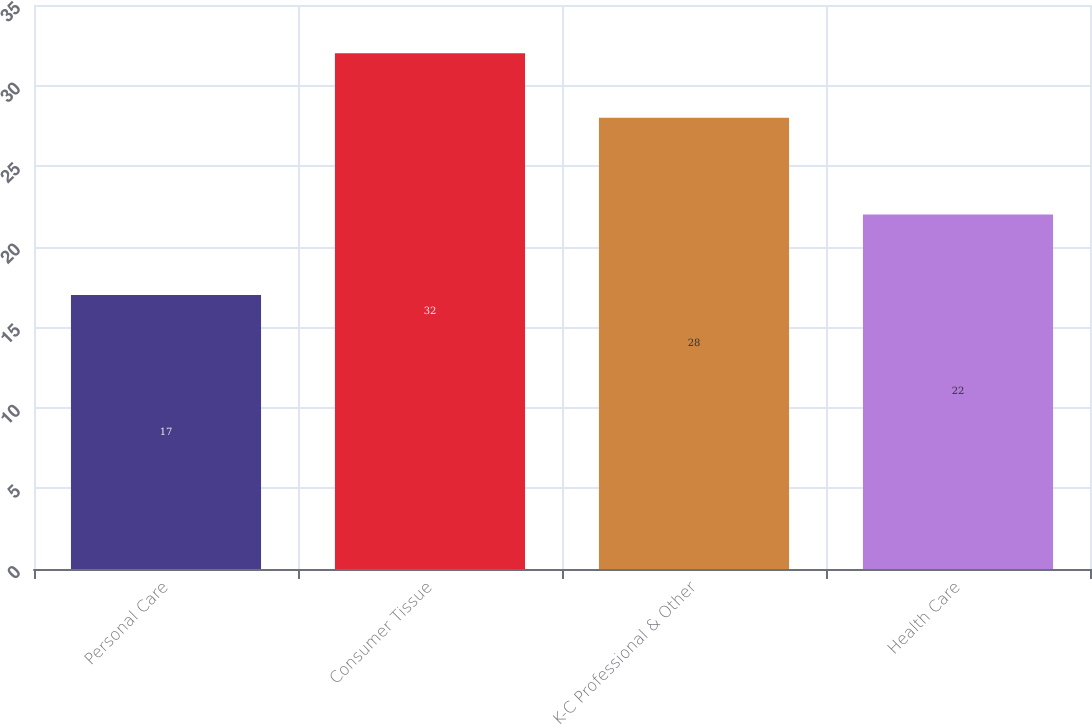Convert chart to OTSL. <chart><loc_0><loc_0><loc_500><loc_500><bar_chart><fcel>Personal Care<fcel>Consumer Tissue<fcel>K-C Professional & Other<fcel>Health Care<nl><fcel>17<fcel>32<fcel>28<fcel>22<nl></chart> 